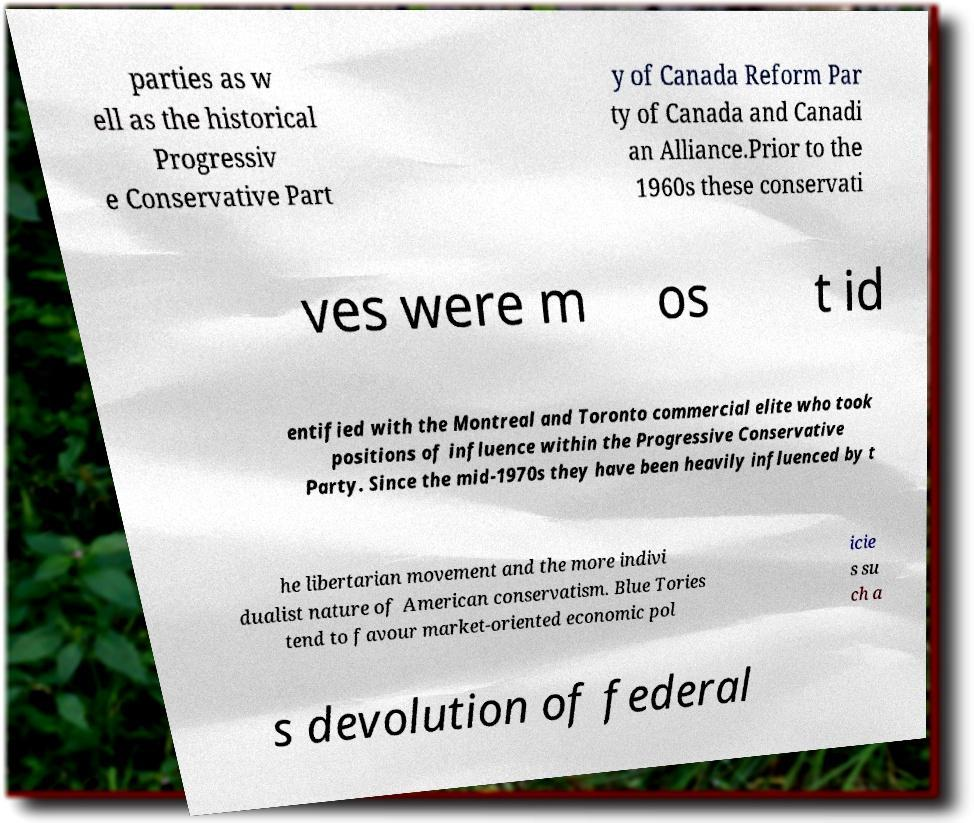Can you accurately transcribe the text from the provided image for me? parties as w ell as the historical Progressiv e Conservative Part y of Canada Reform Par ty of Canada and Canadi an Alliance.Prior to the 1960s these conservati ves were m os t id entified with the Montreal and Toronto commercial elite who took positions of influence within the Progressive Conservative Party. Since the mid-1970s they have been heavily influenced by t he libertarian movement and the more indivi dualist nature of American conservatism. Blue Tories tend to favour market-oriented economic pol icie s su ch a s devolution of federal 